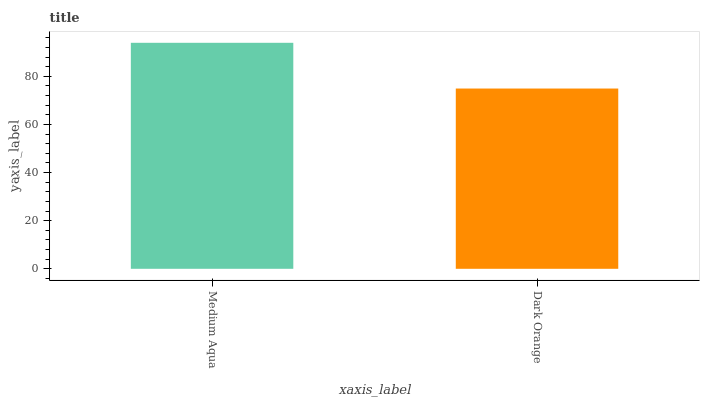Is Dark Orange the minimum?
Answer yes or no. Yes. Is Medium Aqua the maximum?
Answer yes or no. Yes. Is Dark Orange the maximum?
Answer yes or no. No. Is Medium Aqua greater than Dark Orange?
Answer yes or no. Yes. Is Dark Orange less than Medium Aqua?
Answer yes or no. Yes. Is Dark Orange greater than Medium Aqua?
Answer yes or no. No. Is Medium Aqua less than Dark Orange?
Answer yes or no. No. Is Medium Aqua the high median?
Answer yes or no. Yes. Is Dark Orange the low median?
Answer yes or no. Yes. Is Dark Orange the high median?
Answer yes or no. No. Is Medium Aqua the low median?
Answer yes or no. No. 